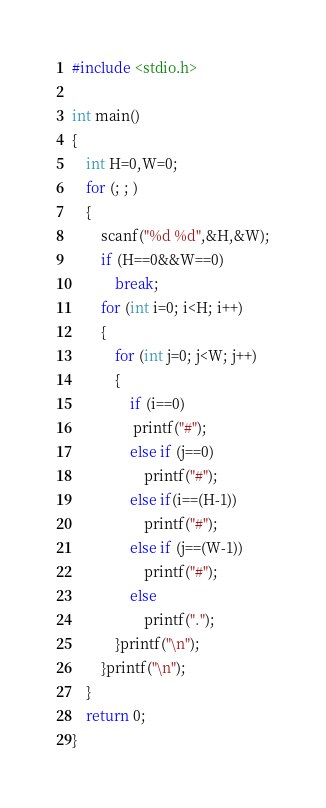Convert code to text. <code><loc_0><loc_0><loc_500><loc_500><_C_>#include <stdio.h>

int main()
{
    int H=0,W=0;
    for (; ; )
    {
        scanf("%d %d",&H,&W);
        if (H==0&&W==0)
            break;
        for (int i=0; i<H; i++)
        {
            for (int j=0; j<W; j++)
            {
                if (i==0)
                 printf("#");
                else if (j==0)
                    printf("#");
                else if(i==(H-1))
                    printf("#");
                else if (j==(W-1))
                    printf("#");
                else
                    printf(".");
            }printf("\n");
        }printf("\n");
    }
    return 0;
}</code> 